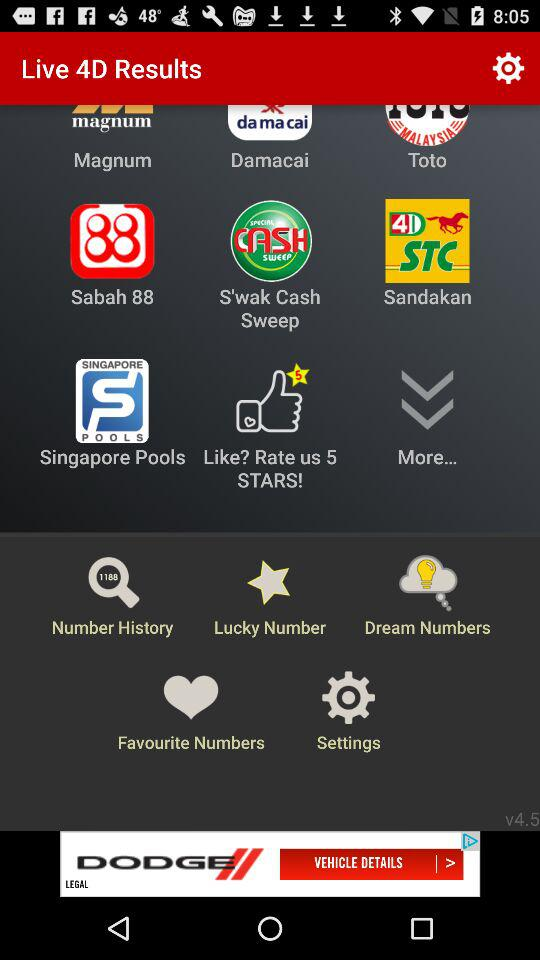Which option is selected in "FREE Result Notifications"? The selected options in "FREE Result Notifications" are "Magnum 4D", "Toto 4D", "Toto 5D", "Toto 6D", "Toto Jackpot (6/63, 6/58, 6/55)", "Damacai 1+3D", "Singapore 4D", "Singapore Toto" and "Sabah 3D". 